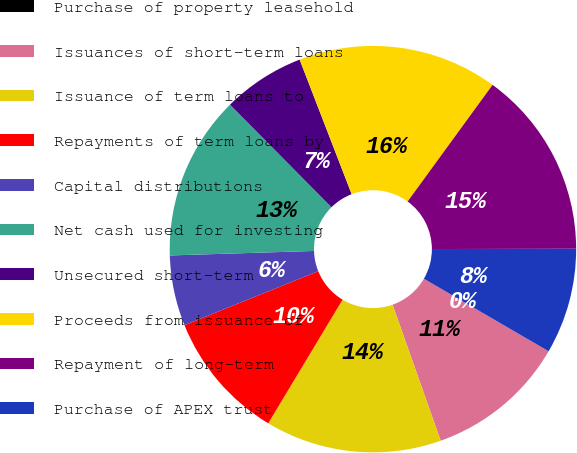Convert chart to OTSL. <chart><loc_0><loc_0><loc_500><loc_500><pie_chart><fcel>Purchase of property leasehold<fcel>Issuances of short-term loans<fcel>Issuance of term loans to<fcel>Repayments of term loans by<fcel>Capital distributions<fcel>Net cash used for investing<fcel>Unsecured short-term<fcel>Proceeds from issuance of<fcel>Repayment of long-term<fcel>Purchase of APEX trust<nl><fcel>0.0%<fcel>11.21%<fcel>14.02%<fcel>10.28%<fcel>5.61%<fcel>13.08%<fcel>6.54%<fcel>15.89%<fcel>14.95%<fcel>8.41%<nl></chart> 